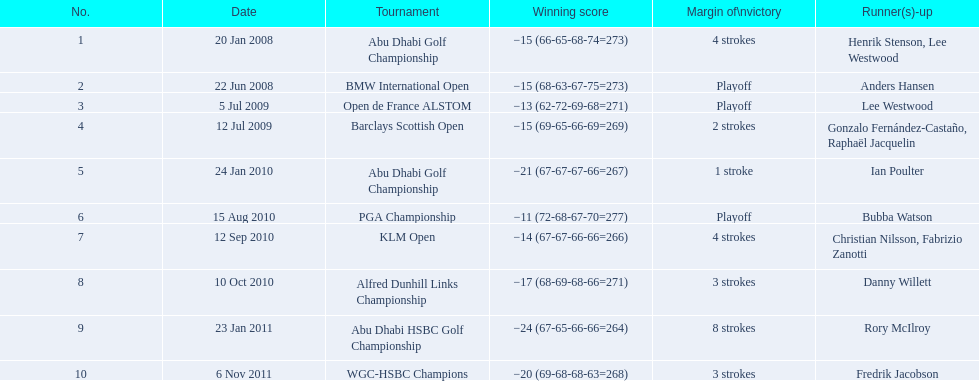Which competitions did martin kaymer take part in? Abu Dhabi Golf Championship, BMW International Open, Open de France ALSTOM, Barclays Scottish Open, Abu Dhabi Golf Championship, PGA Championship, KLM Open, Alfred Dunhill Links Championship, Abu Dhabi HSBC Golf Championship, WGC-HSBC Champions. How many of these events were won via a playoff? BMW International Open, Open de France ALSTOM, PGA Championship. Which of those competitions occurred in 2010? PGA Championship. Who had the highest score alongside martin kaymer for that tournament? Bubba Watson. 